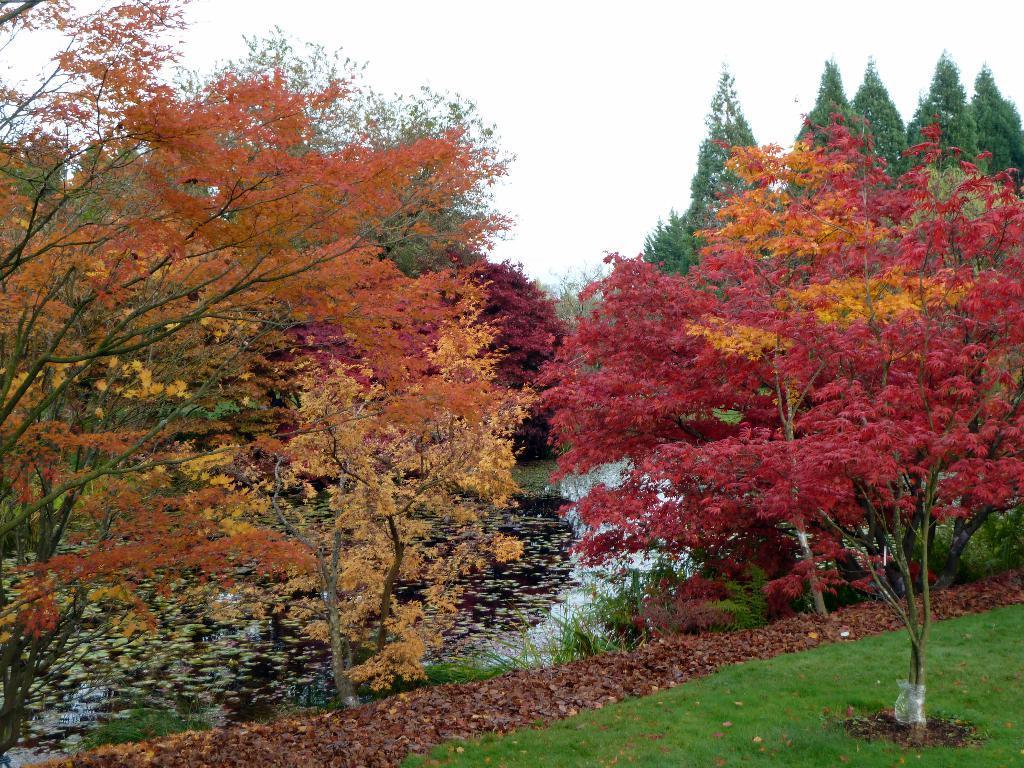In one or two sentences, can you explain what this image depicts? In this image we can see so many tree. Behind the trees water is present. Right bottom of the image we can see some grassy land. 